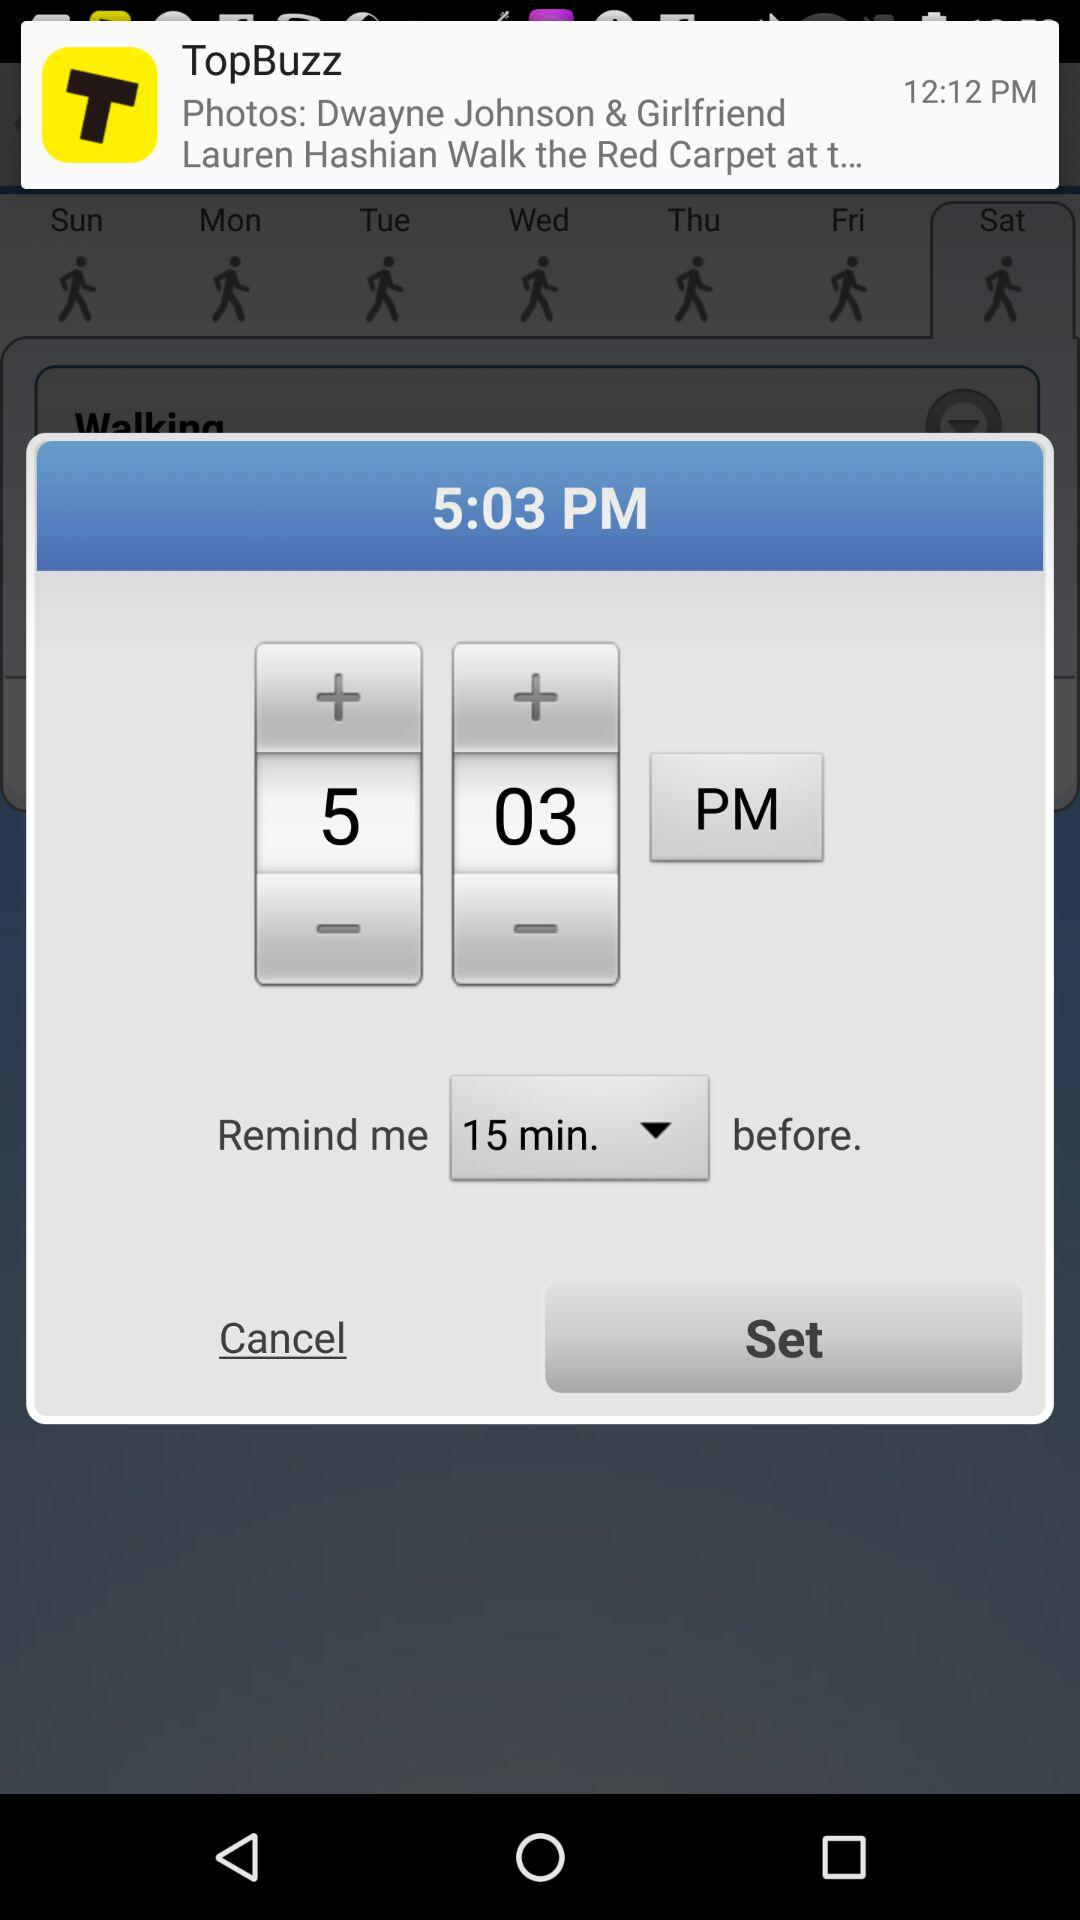When will it remind the user? It will remind the user 15 minutes before. 